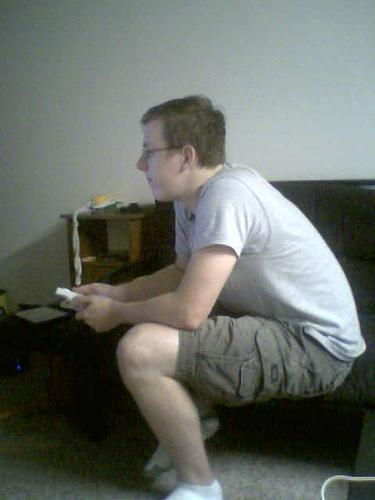What type of furniture is the boy sitting on? sofa 